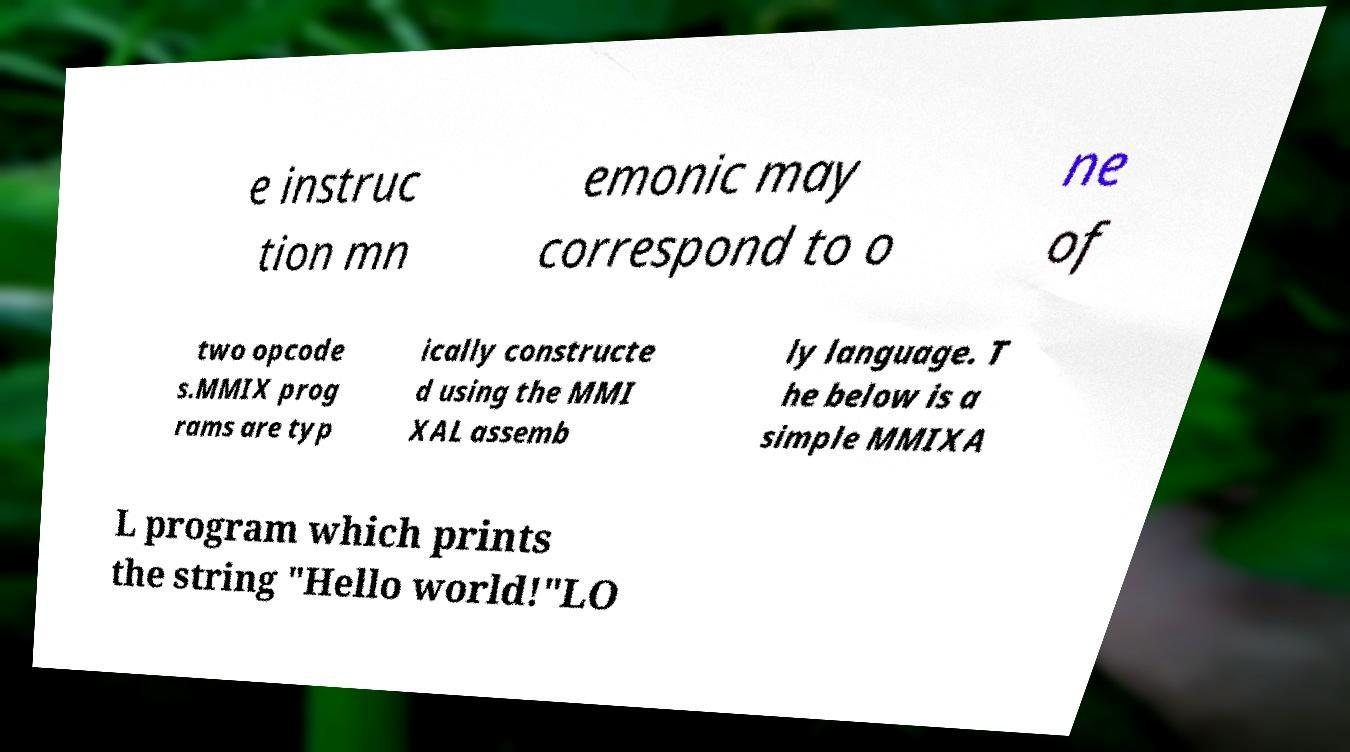Could you assist in decoding the text presented in this image and type it out clearly? e instruc tion mn emonic may correspond to o ne of two opcode s.MMIX prog rams are typ ically constructe d using the MMI XAL assemb ly language. T he below is a simple MMIXA L program which prints the string "Hello world!"LO 